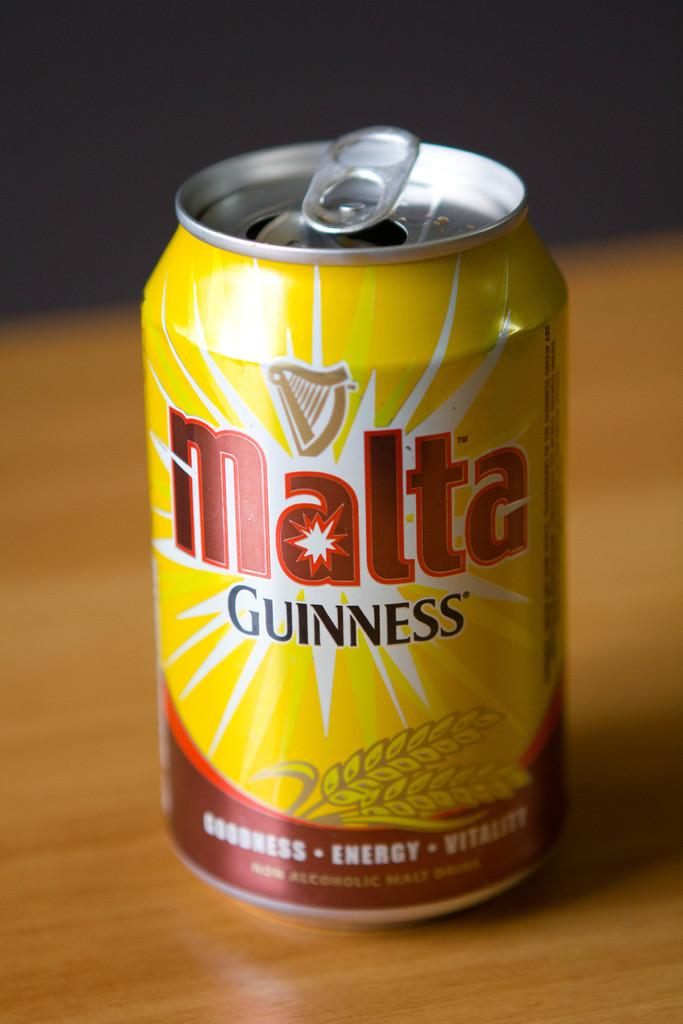Provide a one-sentence caption for the provided image. A can of malta Guiness contains a non-alcoholic malt drink. 